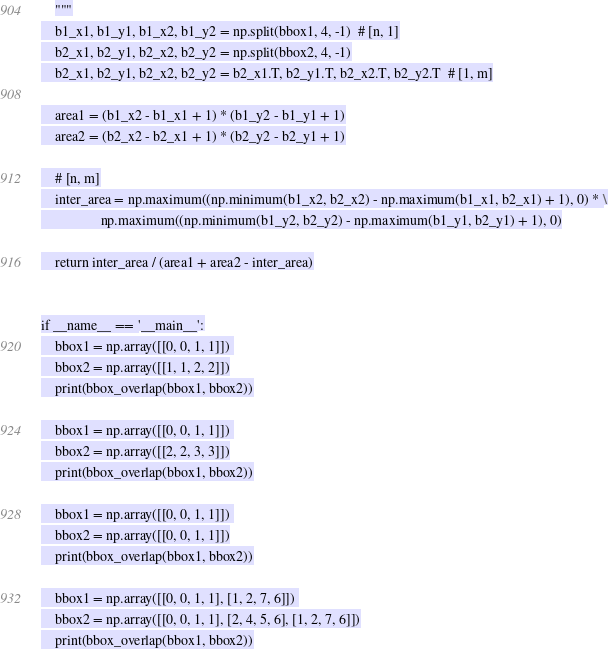Convert code to text. <code><loc_0><loc_0><loc_500><loc_500><_Python_>    """
    b1_x1, b1_y1, b1_x2, b1_y2 = np.split(bbox1, 4, -1)  # [n, 1]
    b2_x1, b2_y1, b2_x2, b2_y2 = np.split(bbox2, 4, -1)
    b2_x1, b2_y1, b2_x2, b2_y2 = b2_x1.T, b2_y1.T, b2_x2.T, b2_y2.T  # [1, m]

    area1 = (b1_x2 - b1_x1 + 1) * (b1_y2 - b1_y1 + 1)
    area2 = (b2_x2 - b2_x1 + 1) * (b2_y2 - b2_y1 + 1)

    # [n, m]
    inter_area = np.maximum((np.minimum(b1_x2, b2_x2) - np.maximum(b1_x1, b2_x1) + 1), 0) * \
                 np.maximum((np.minimum(b1_y2, b2_y2) - np.maximum(b1_y1, b2_y1) + 1), 0)

    return inter_area / (area1 + area2 - inter_area)


if __name__ == '__main__':
    bbox1 = np.array([[0, 0, 1, 1]]) 
    bbox2 = np.array([[1, 1, 2, 2]])
    print(bbox_overlap(bbox1, bbox2))

    bbox1 = np.array([[0, 0, 1, 1]]) 
    bbox2 = np.array([[2, 2, 3, 3]])
    print(bbox_overlap(bbox1, bbox2))

    bbox1 = np.array([[0, 0, 1, 1]]) 
    bbox2 = np.array([[0, 0, 1, 1]])
    print(bbox_overlap(bbox1, bbox2))

    bbox1 = np.array([[0, 0, 1, 1], [1, 2, 7, 6]]) 
    bbox2 = np.array([[0, 0, 1, 1], [2, 4, 5, 6], [1, 2, 7, 6]])
    print(bbox_overlap(bbox1, bbox2))
</code> 